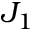<formula> <loc_0><loc_0><loc_500><loc_500>J _ { 1 }</formula> 